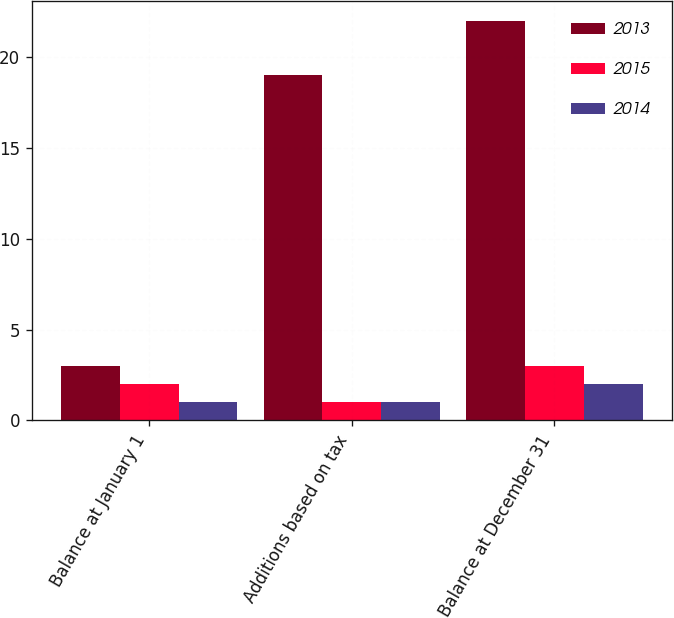Convert chart to OTSL. <chart><loc_0><loc_0><loc_500><loc_500><stacked_bar_chart><ecel><fcel>Balance at January 1<fcel>Additions based on tax<fcel>Balance at December 31<nl><fcel>2013<fcel>3<fcel>19<fcel>22<nl><fcel>2015<fcel>2<fcel>1<fcel>3<nl><fcel>2014<fcel>1<fcel>1<fcel>2<nl></chart> 